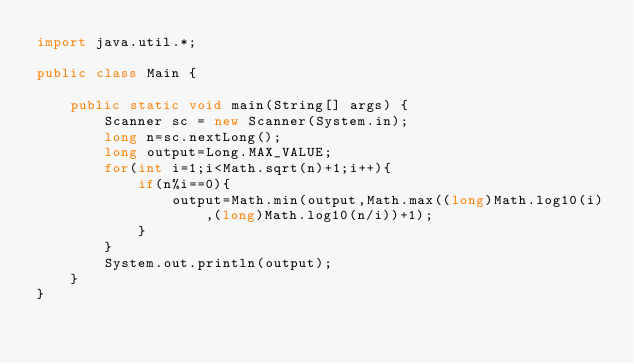<code> <loc_0><loc_0><loc_500><loc_500><_Java_>import java.util.*;
 
public class Main {
 
    public static void main(String[] args) {
        Scanner sc = new Scanner(System.in);
        long n=sc.nextLong();
        long output=Long.MAX_VALUE;
        for(int i=1;i<Math.sqrt(n)+1;i++){
            if(n%i==0){
                output=Math.min(output,Math.max((long)Math.log10(i),(long)Math.log10(n/i))+1);
            }
        }
        System.out.println(output);
    }
}</code> 